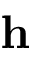Convert formula to latex. <formula><loc_0><loc_0><loc_500><loc_500>{ h }</formula> 